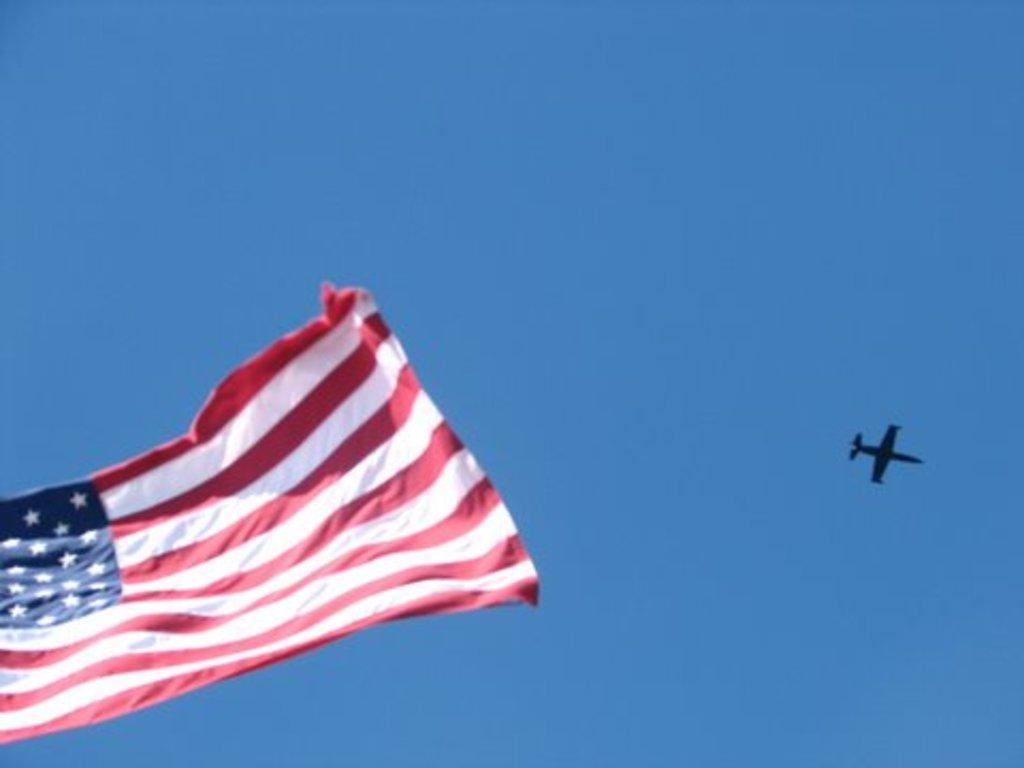What is present in the image that represents a country or organization? There is a flag in the image. What mode of transportation can be seen in the image? There is an airplane in the air in the image. What part of the natural environment is visible in the image? The sky is visible in the background of the image. What type of neck patch can be seen on the airplane in the image? There is no neck patch visible on the airplane in the image. What fictional character might be flying the airplane in the image? The image does not depict any fictional characters, and the identity of the airplane pilot is not known. 